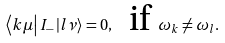<formula> <loc_0><loc_0><loc_500><loc_500>\left \langle k \mu \right | I _ { - } \left | l \nu \right \rangle = 0 , \text { \ if } \omega _ { k } \neq \omega _ { l } .</formula> 